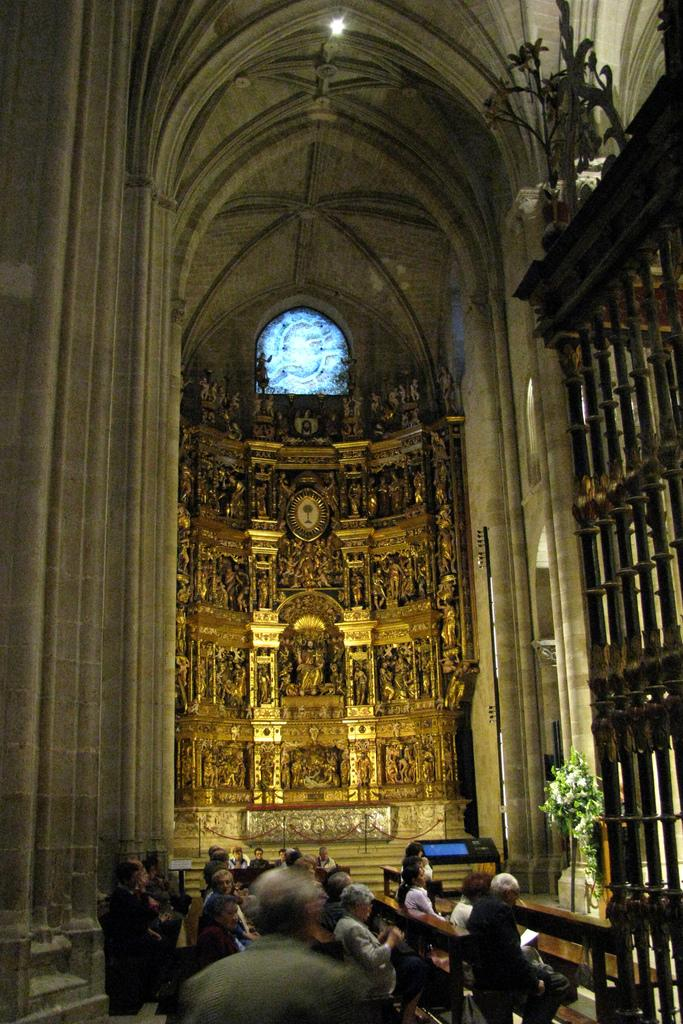What is the main structure in the image? There is a huge building in the image. What are people doing inside the building? People are sitting on benches inside the building. Is there anyone standing in front of the people? Yes, there is a man standing in front of the people. How many rabbits can be seen playing with the man in the image? There are no rabbits present in the image, and the man is not interacting with any animals. What is the relationship between the man and the people sitting on the benches? The provided facts do not specify the relationship between the man and the people sitting on the benches. 